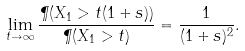<formula> <loc_0><loc_0><loc_500><loc_500>\lim _ { t \to \infty } \frac { \P ( X _ { 1 } > t ( 1 + s ) ) } { \P ( X _ { 1 } > t ) } = \frac { 1 } { ( 1 + s ) ^ { 2 } } .</formula> 